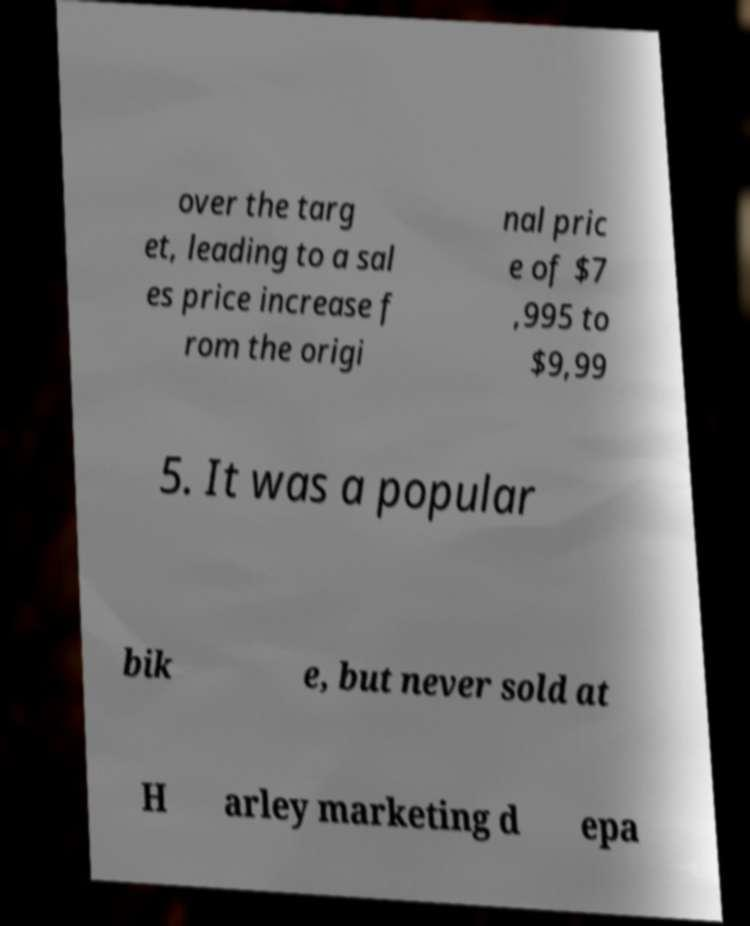Could you extract and type out the text from this image? over the targ et, leading to a sal es price increase f rom the origi nal pric e of $7 ,995 to $9,99 5. It was a popular bik e, but never sold at H arley marketing d epa 